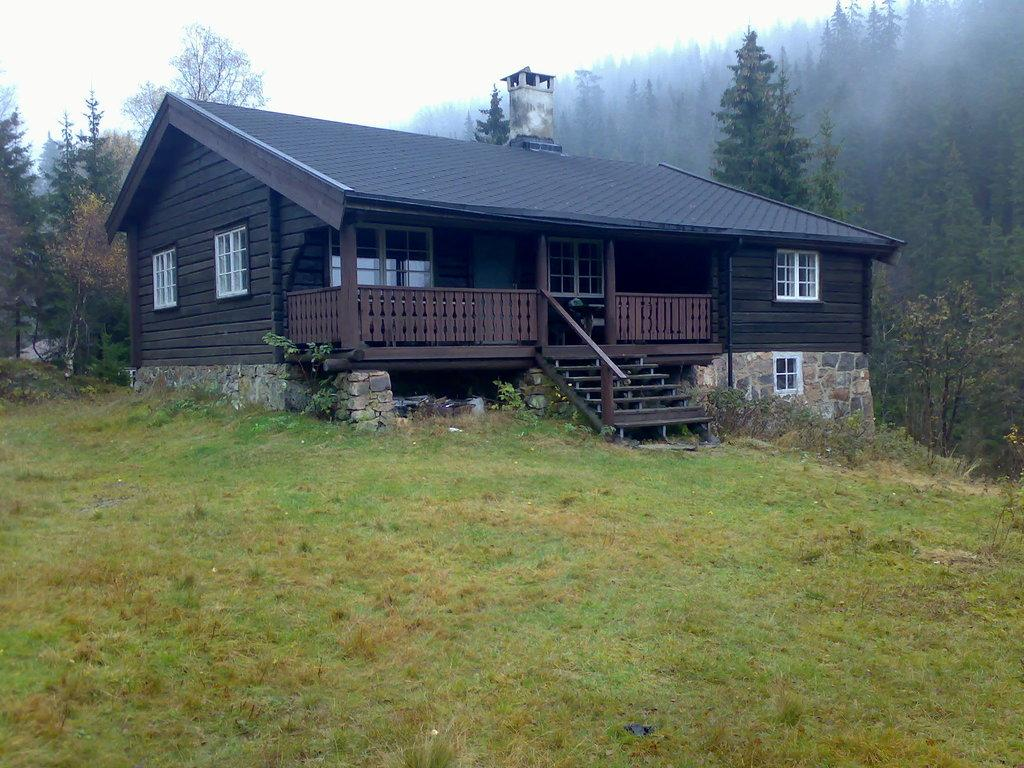What type of structure is in the image? There is a house in the image. What features can be seen on the house? The house has windows and stairs. What type of vegetation is visible in the image? There is grass visible in the image. What can be seen in the background of the image? There are trees in the background of the image. What are the trees like? The trees have branches and leaves. Can you tell me how many people are standing in the shade of the trees in the image? There are no people visible in the image, and therefore no one is standing in the shade of the trees. 